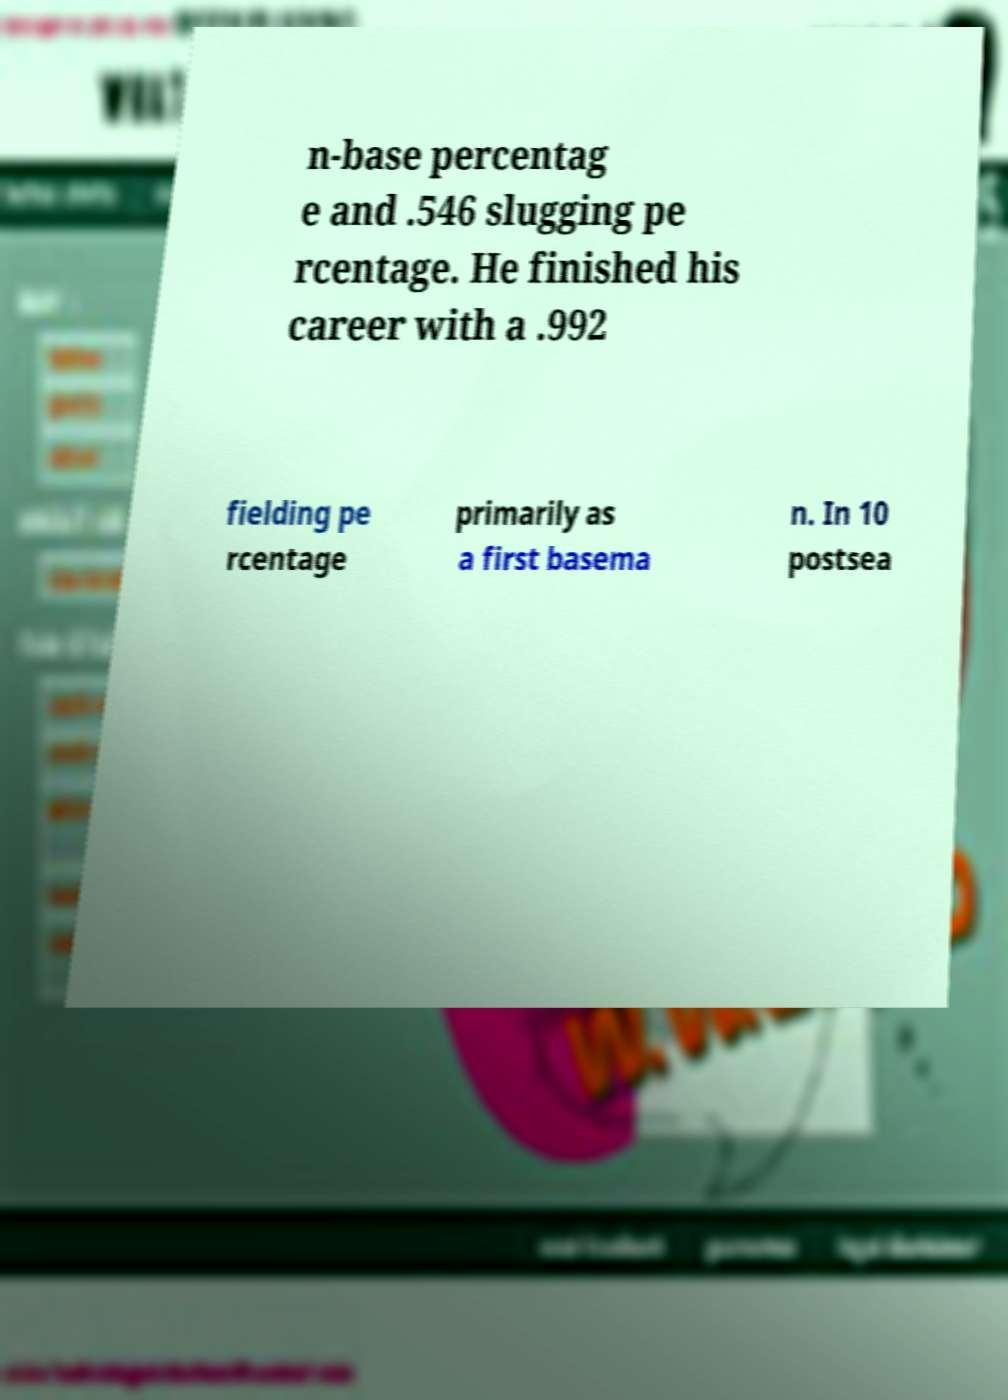For documentation purposes, I need the text within this image transcribed. Could you provide that? n-base percentag e and .546 slugging pe rcentage. He finished his career with a .992 fielding pe rcentage primarily as a first basema n. In 10 postsea 